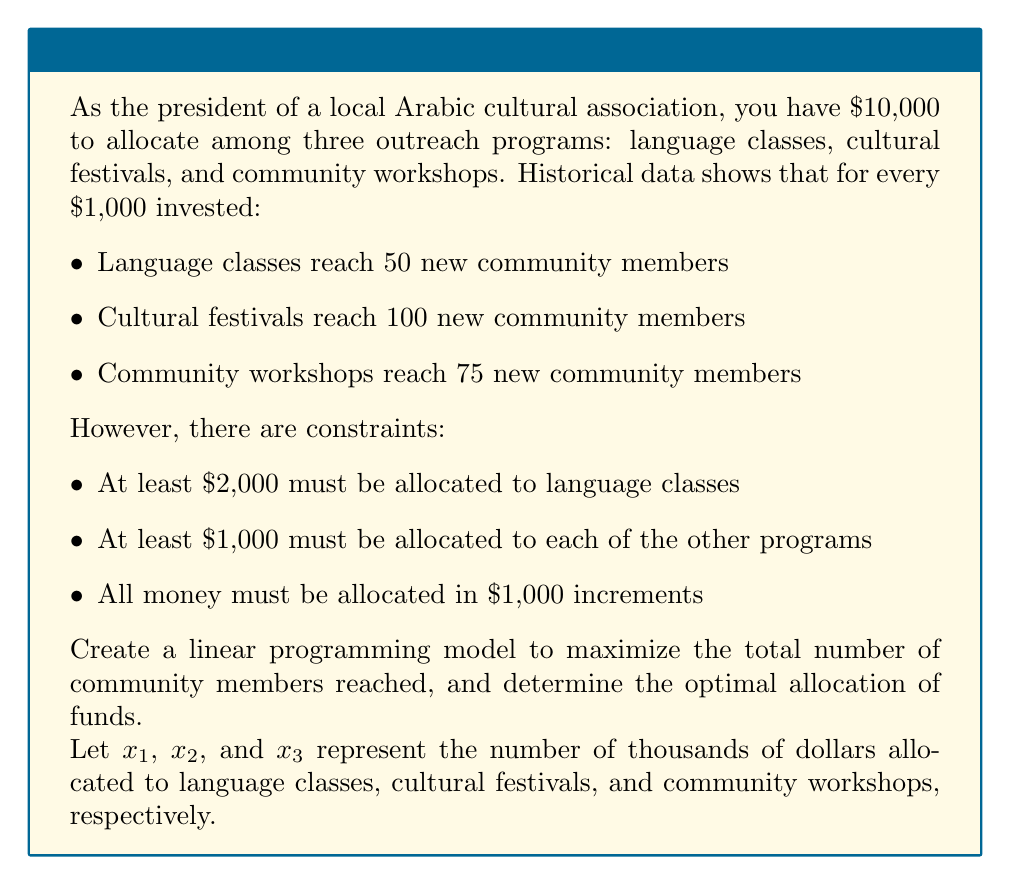Can you solve this math problem? To solve this linear programming problem, we'll follow these steps:

1) Define the objective function:
   Maximize $Z = 50x_1 + 100x_2 + 75x_3$

2) List the constraints:
   $x_1 \geq 2$ (at least $2,000 for language classes)
   $x_2 \geq 1$ (at least $1,000 for cultural festivals)
   $x_3 \geq 1$ (at least $1,000 for community workshops)
   $x_1 + x_2 + x_3 = 10$ (total budget constraint)
   $x_1, x_2, x_3$ are integers

3) Solve using the simplex method or integer programming software. However, given the small number of integer solutions, we can enumerate them:

   Possible allocations $(x_1, x_2, x_3)$:
   (2, 1, 7), (2, 2, 6), (2, 3, 5), (2, 4, 4), (2, 5, 3), (2, 6, 2), (2, 7, 1)
   (3, 1, 6), (3, 2, 5), (3, 3, 4), (3, 4, 3), (3, 5, 2), (3, 6, 1)
   (4, 1, 5), (4, 2, 4), (4, 3, 3), (4, 4, 2), (4, 5, 1)
   (5, 1, 4), (5, 2, 3), (5, 3, 2), (5, 4, 1)
   (6, 1, 3), (6, 2, 2), (6, 3, 1)
   (7, 1, 2), (7, 2, 1)
   (8, 1, 1)

4) Calculate the objective function value for each allocation:

   The maximum value is 825, achieved with the allocation (2, 7, 1).

5) Interpret the result:
   Optimal allocation: $2,000 for language classes, $7,000 for cultural festivals, and $1,000 for community workshops.
   This reaches 50(2) + 100(7) + 75(1) = 825 community members.
Answer: Language classes: $2,000; Cultural festivals: $7,000; Community workshops: $1,000 